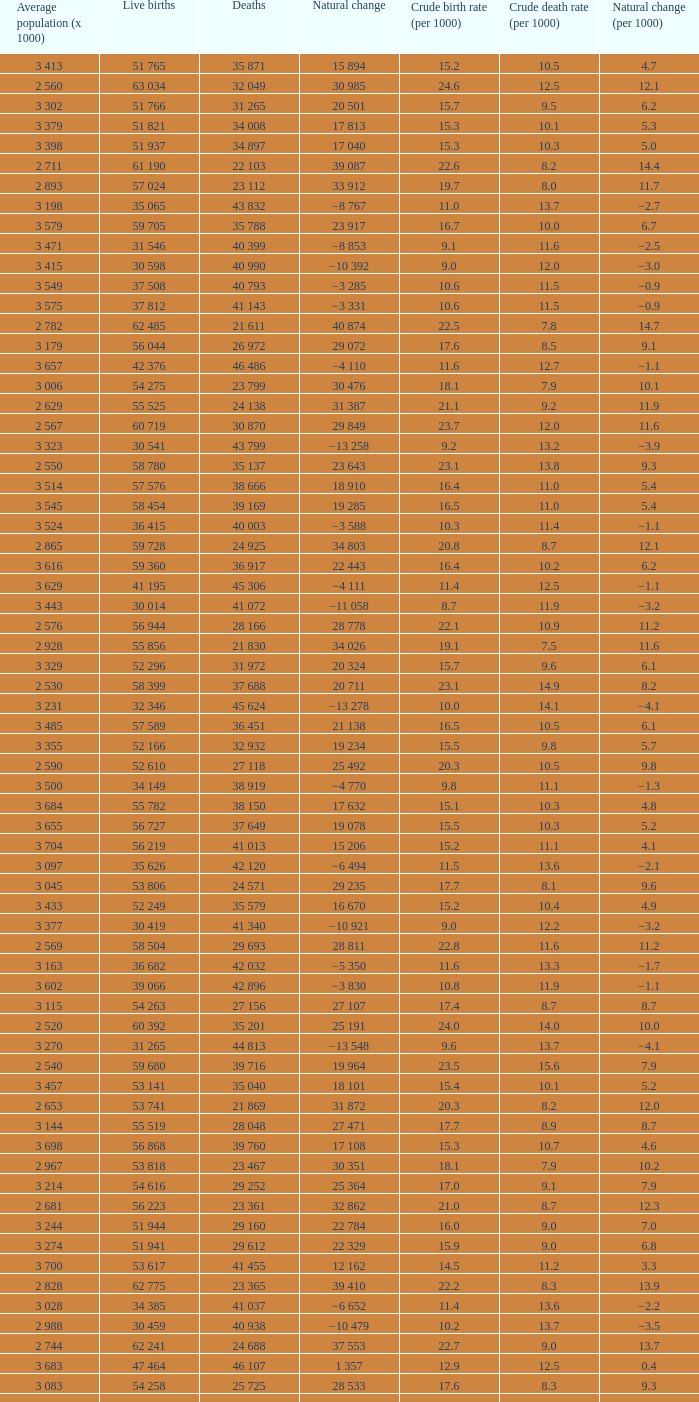Which Live births have a Natural change (per 1000) of 12.0? 53 741. 